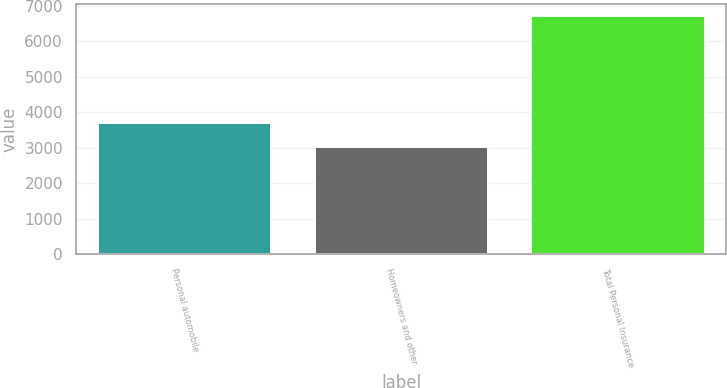<chart> <loc_0><loc_0><loc_500><loc_500><bar_chart><fcel>Personal automobile<fcel>Homeowners and other<fcel>Total Personal Insurance<nl><fcel>3692<fcel>3019<fcel>6711<nl></chart> 